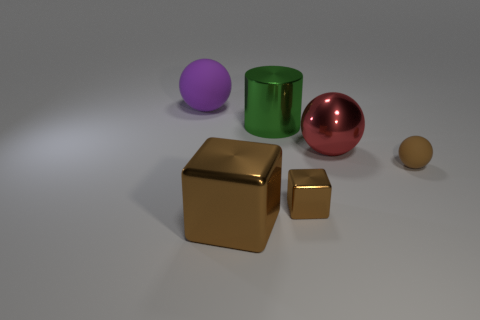Add 3 big green metal objects. How many objects exist? 9 Subtract all blocks. How many objects are left? 4 Add 2 small brown objects. How many small brown objects are left? 4 Add 3 large green shiny cylinders. How many large green shiny cylinders exist? 4 Subtract 1 green cylinders. How many objects are left? 5 Subtract all green cylinders. Subtract all spheres. How many objects are left? 2 